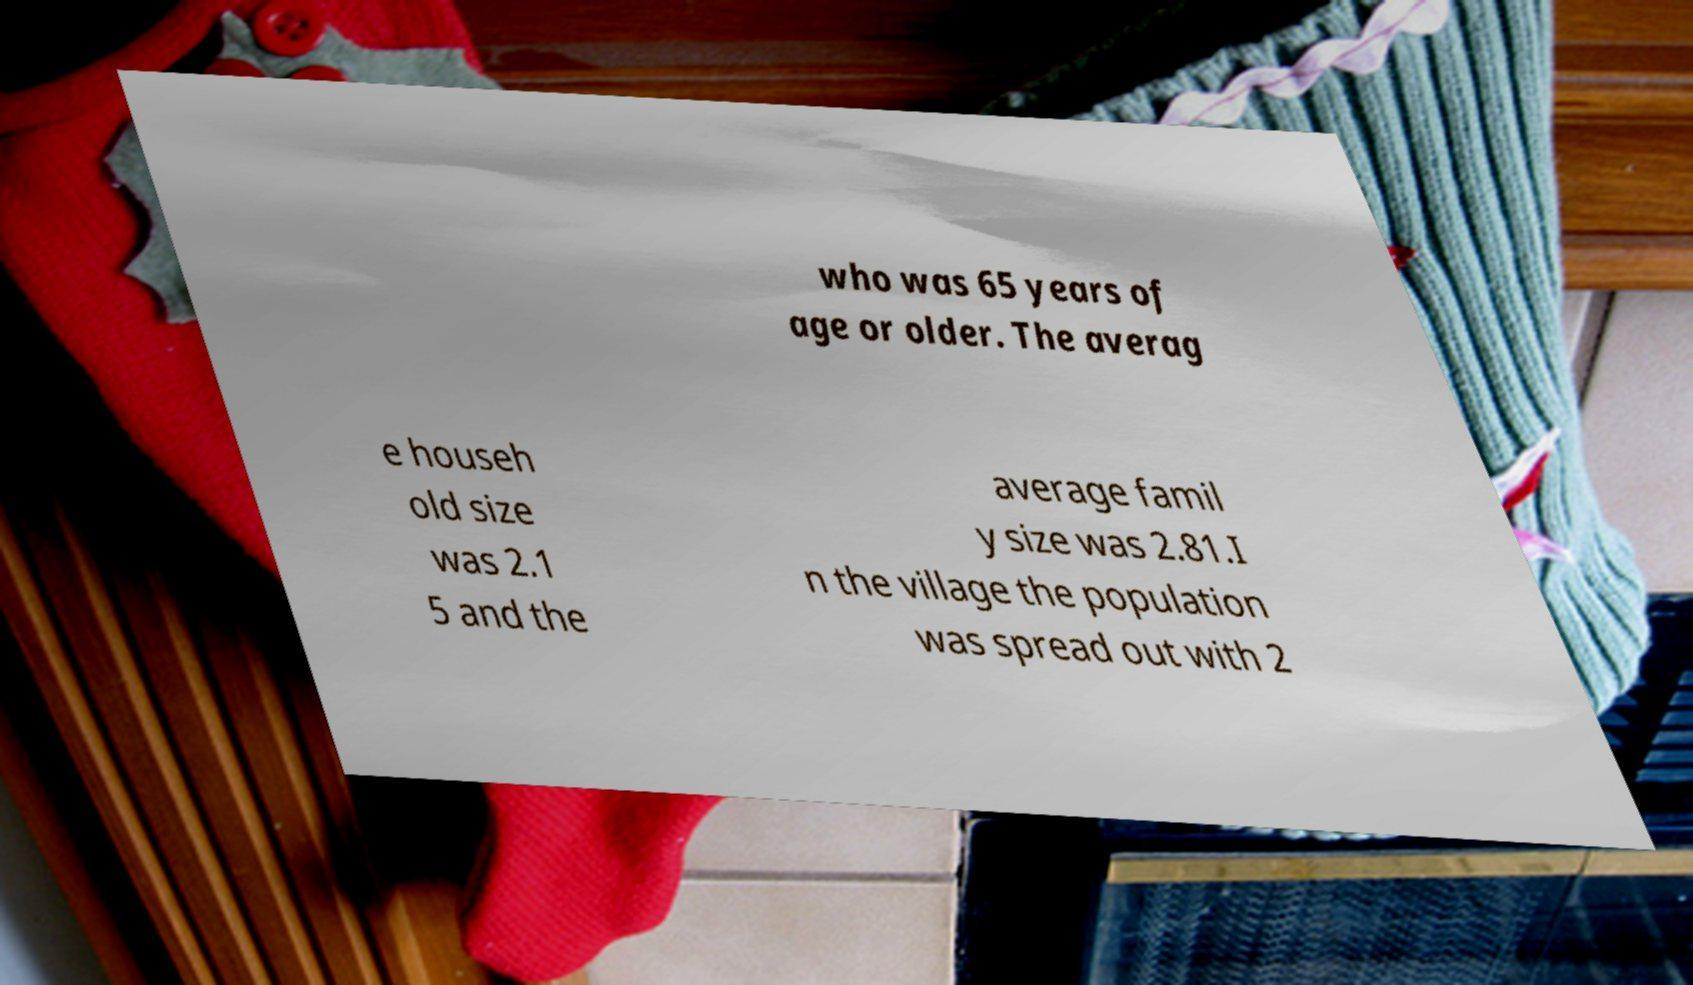Please identify and transcribe the text found in this image. who was 65 years of age or older. The averag e househ old size was 2.1 5 and the average famil y size was 2.81.I n the village the population was spread out with 2 